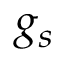Convert formula to latex. <formula><loc_0><loc_0><loc_500><loc_500>g _ { s }</formula> 